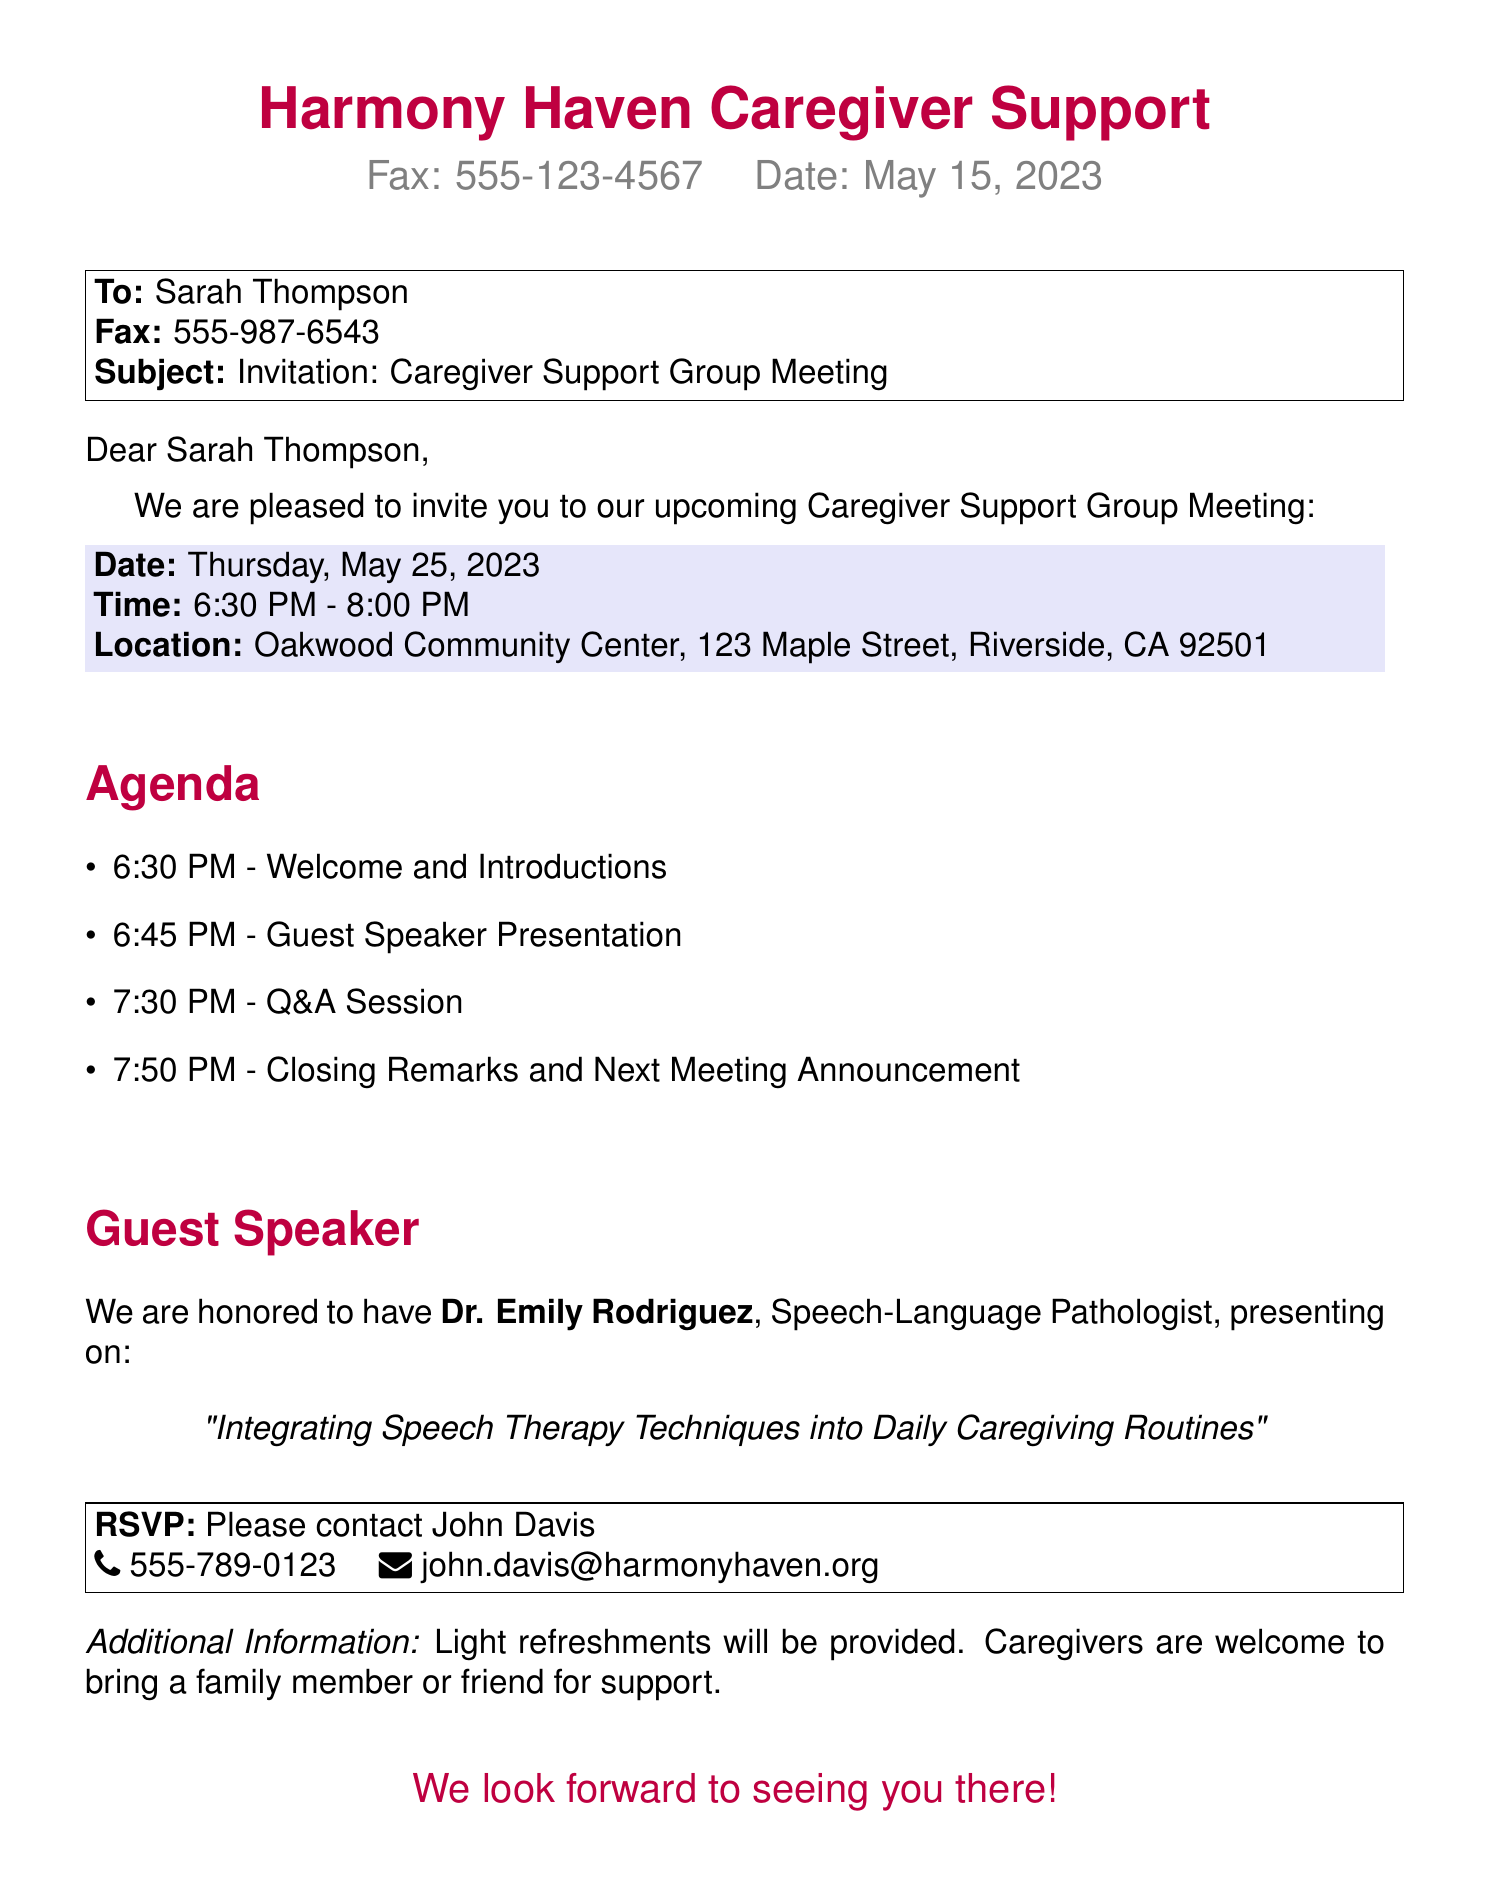What is the date of the meeting? The date of the meeting is explicitly stated in the document.
Answer: Thursday, May 25, 2023 What time does the meeting start? The start time of the meeting is indicated directly in the document.
Answer: 6:30 PM Who is the guest speaker? The document specifies the name of the guest speaker in the guest speaker section.
Answer: Dr. Emily Rodriguez What is the location of the meeting? The location is clearly mentioned in the document under the details of the meeting.
Answer: Oakwood Community Center, 123 Maple Street, Riverside, CA 92501 What is the topic of the guest speaker's presentation? The topic is provided in the document and directly reflects the focus of the presentation.
Answer: Integrating Speech Therapy Techniques into Daily Caregiving Routines How long is the Q&A session scheduled to last? The duration of the Q&A session can be calculated from the agenda provided in the document.
Answer: 20 minutes What is the RSVP contact’s name? The document specifies the name of the person to contact for the RSVP.
Answer: John Davis Will refreshments be provided? The document includes a note about the availability of refreshments.
Answer: Yes How many items are listed in the agenda? The total number of agenda items can be counted from the list presented in the document.
Answer: 4 items 